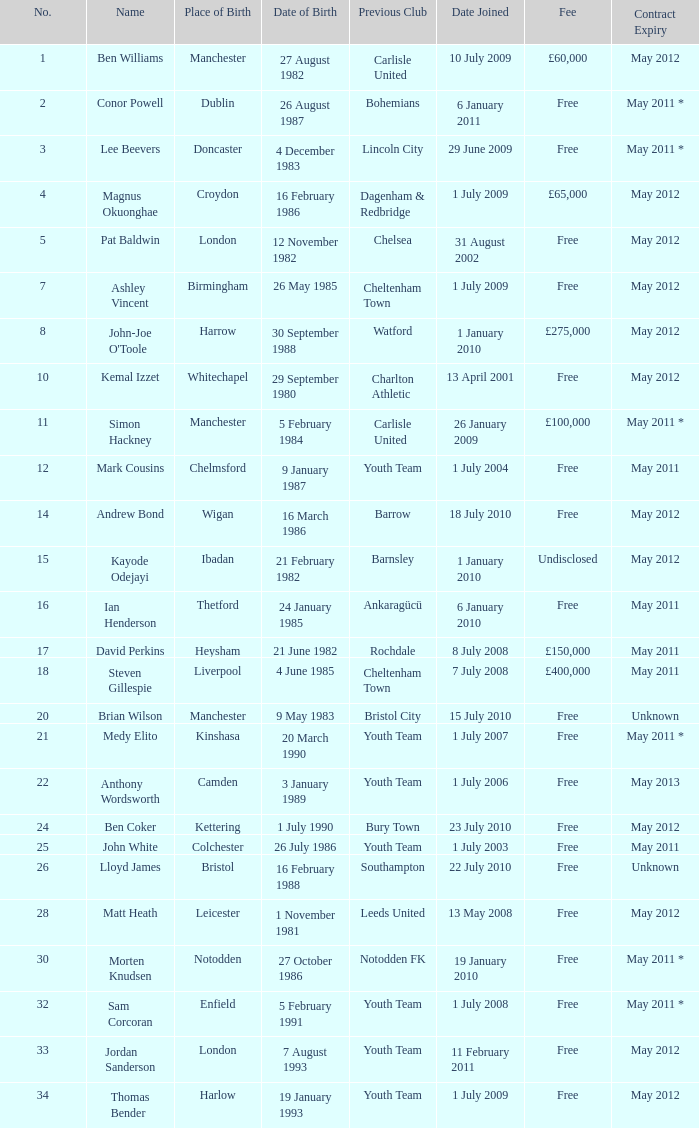For the ben williams name what was the previous club Carlisle United. 